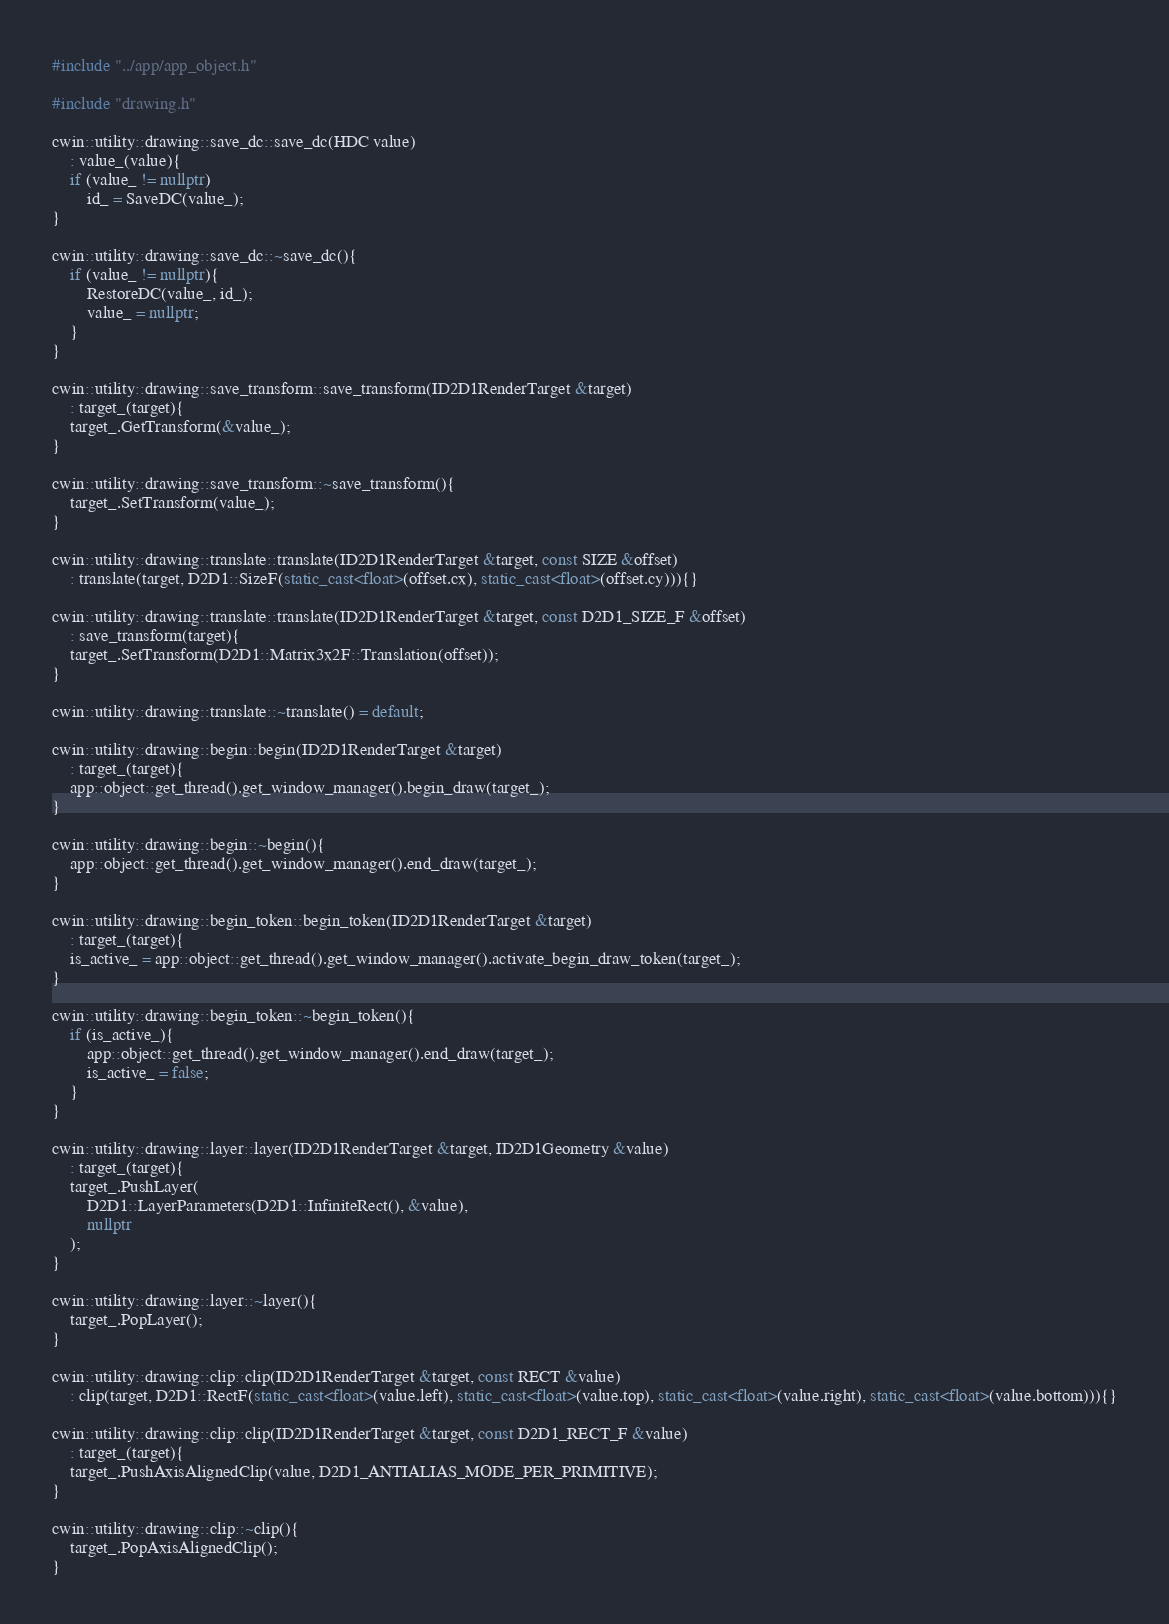<code> <loc_0><loc_0><loc_500><loc_500><_C++_>#include "../app/app_object.h"

#include "drawing.h"

cwin::utility::drawing::save_dc::save_dc(HDC value)
	: value_(value){
	if (value_ != nullptr)
		id_ = SaveDC(value_);
}

cwin::utility::drawing::save_dc::~save_dc(){
	if (value_ != nullptr){
		RestoreDC(value_, id_);
		value_ = nullptr;
	}
}

cwin::utility::drawing::save_transform::save_transform(ID2D1RenderTarget &target)
	: target_(target){
	target_.GetTransform(&value_);
}

cwin::utility::drawing::save_transform::~save_transform(){
	target_.SetTransform(value_);
}

cwin::utility::drawing::translate::translate(ID2D1RenderTarget &target, const SIZE &offset)
	: translate(target, D2D1::SizeF(static_cast<float>(offset.cx), static_cast<float>(offset.cy))){}

cwin::utility::drawing::translate::translate(ID2D1RenderTarget &target, const D2D1_SIZE_F &offset)
	: save_transform(target){
	target_.SetTransform(D2D1::Matrix3x2F::Translation(offset));
}

cwin::utility::drawing::translate::~translate() = default;

cwin::utility::drawing::begin::begin(ID2D1RenderTarget &target)
	: target_(target){
	app::object::get_thread().get_window_manager().begin_draw(target_);
}

cwin::utility::drawing::begin::~begin(){
	app::object::get_thread().get_window_manager().end_draw(target_);
}

cwin::utility::drawing::begin_token::begin_token(ID2D1RenderTarget &target)
	: target_(target){
	is_active_ = app::object::get_thread().get_window_manager().activate_begin_draw_token(target_);
}

cwin::utility::drawing::begin_token::~begin_token(){
	if (is_active_){
		app::object::get_thread().get_window_manager().end_draw(target_);
		is_active_ = false;
	}
}

cwin::utility::drawing::layer::layer(ID2D1RenderTarget &target, ID2D1Geometry &value)
	: target_(target){
	target_.PushLayer(
		D2D1::LayerParameters(D2D1::InfiniteRect(), &value),
		nullptr
	);
}

cwin::utility::drawing::layer::~layer(){
	target_.PopLayer();
}

cwin::utility::drawing::clip::clip(ID2D1RenderTarget &target, const RECT &value)
	: clip(target, D2D1::RectF(static_cast<float>(value.left), static_cast<float>(value.top), static_cast<float>(value.right), static_cast<float>(value.bottom))){}

cwin::utility::drawing::clip::clip(ID2D1RenderTarget &target, const D2D1_RECT_F &value)
	: target_(target){
	target_.PushAxisAlignedClip(value, D2D1_ANTIALIAS_MODE_PER_PRIMITIVE);
}

cwin::utility::drawing::clip::~clip(){
	target_.PopAxisAlignedClip();
}
</code> 